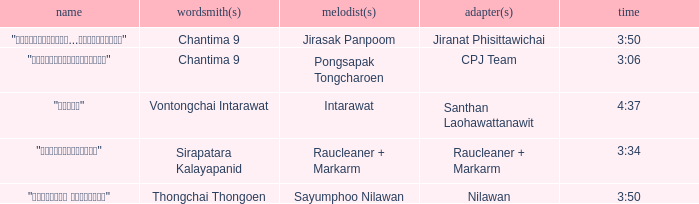Who was the arranger of "ขอโทษ"? Santhan Laohawattanawit. 